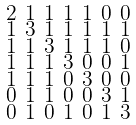Convert formula to latex. <formula><loc_0><loc_0><loc_500><loc_500>\begin{smallmatrix} 2 & 1 & 1 & 1 & 1 & 0 & 0 \\ 1 & 3 & 1 & 1 & 1 & 1 & 1 \\ 1 & 1 & 3 & 1 & 1 & 1 & 0 \\ 1 & 1 & 1 & 3 & 0 & 0 & 1 \\ 1 & 1 & 1 & 0 & 3 & 0 & 0 \\ 0 & 1 & 1 & 0 & 0 & 3 & 1 \\ 0 & 1 & 0 & 1 & 0 & 1 & 3 \end{smallmatrix}</formula> 